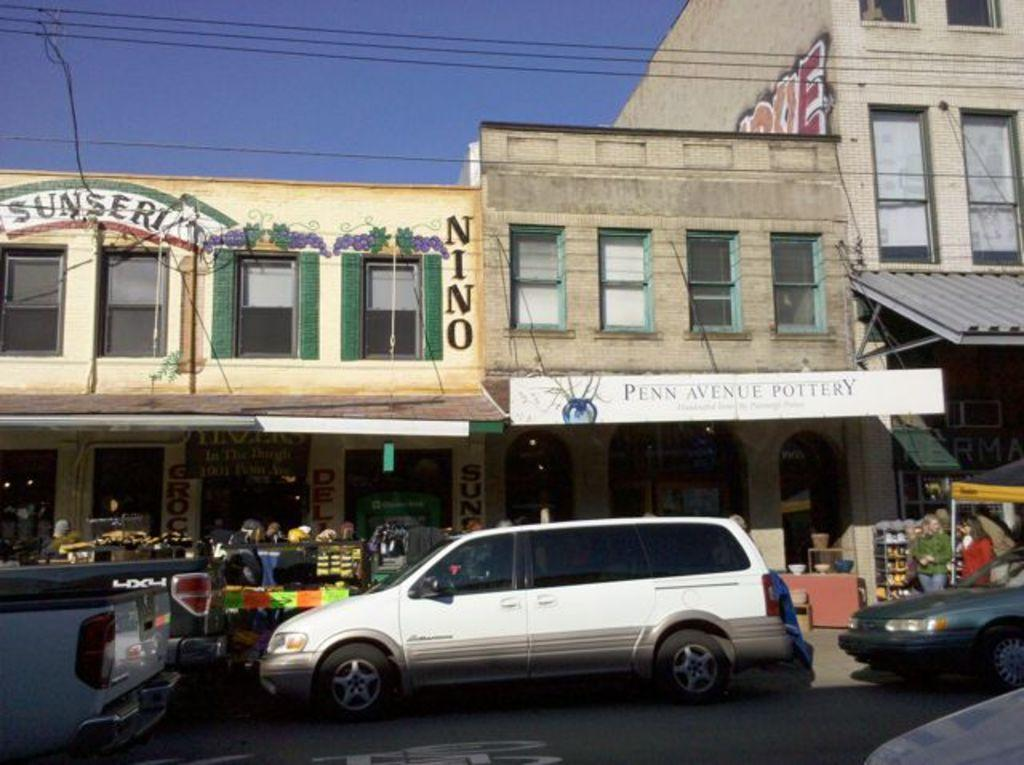What can be seen on the road in the image? There are cars on the road in the image. What is visible in the background of the image? Buildings, banners, people, shops, and objects are visible in the background of the image. What is the condition of the sky in the image? The sky is visible at the top of the image. What else can be seen at the top of the image? Wires are present at the top of the image. Can you tell me how many buns are being used in the argument in the image? There is no argument or buns present in the image. What type of power is being generated by the cars in the image? The cars in the image are not generating any power; they are simply moving on the road. 